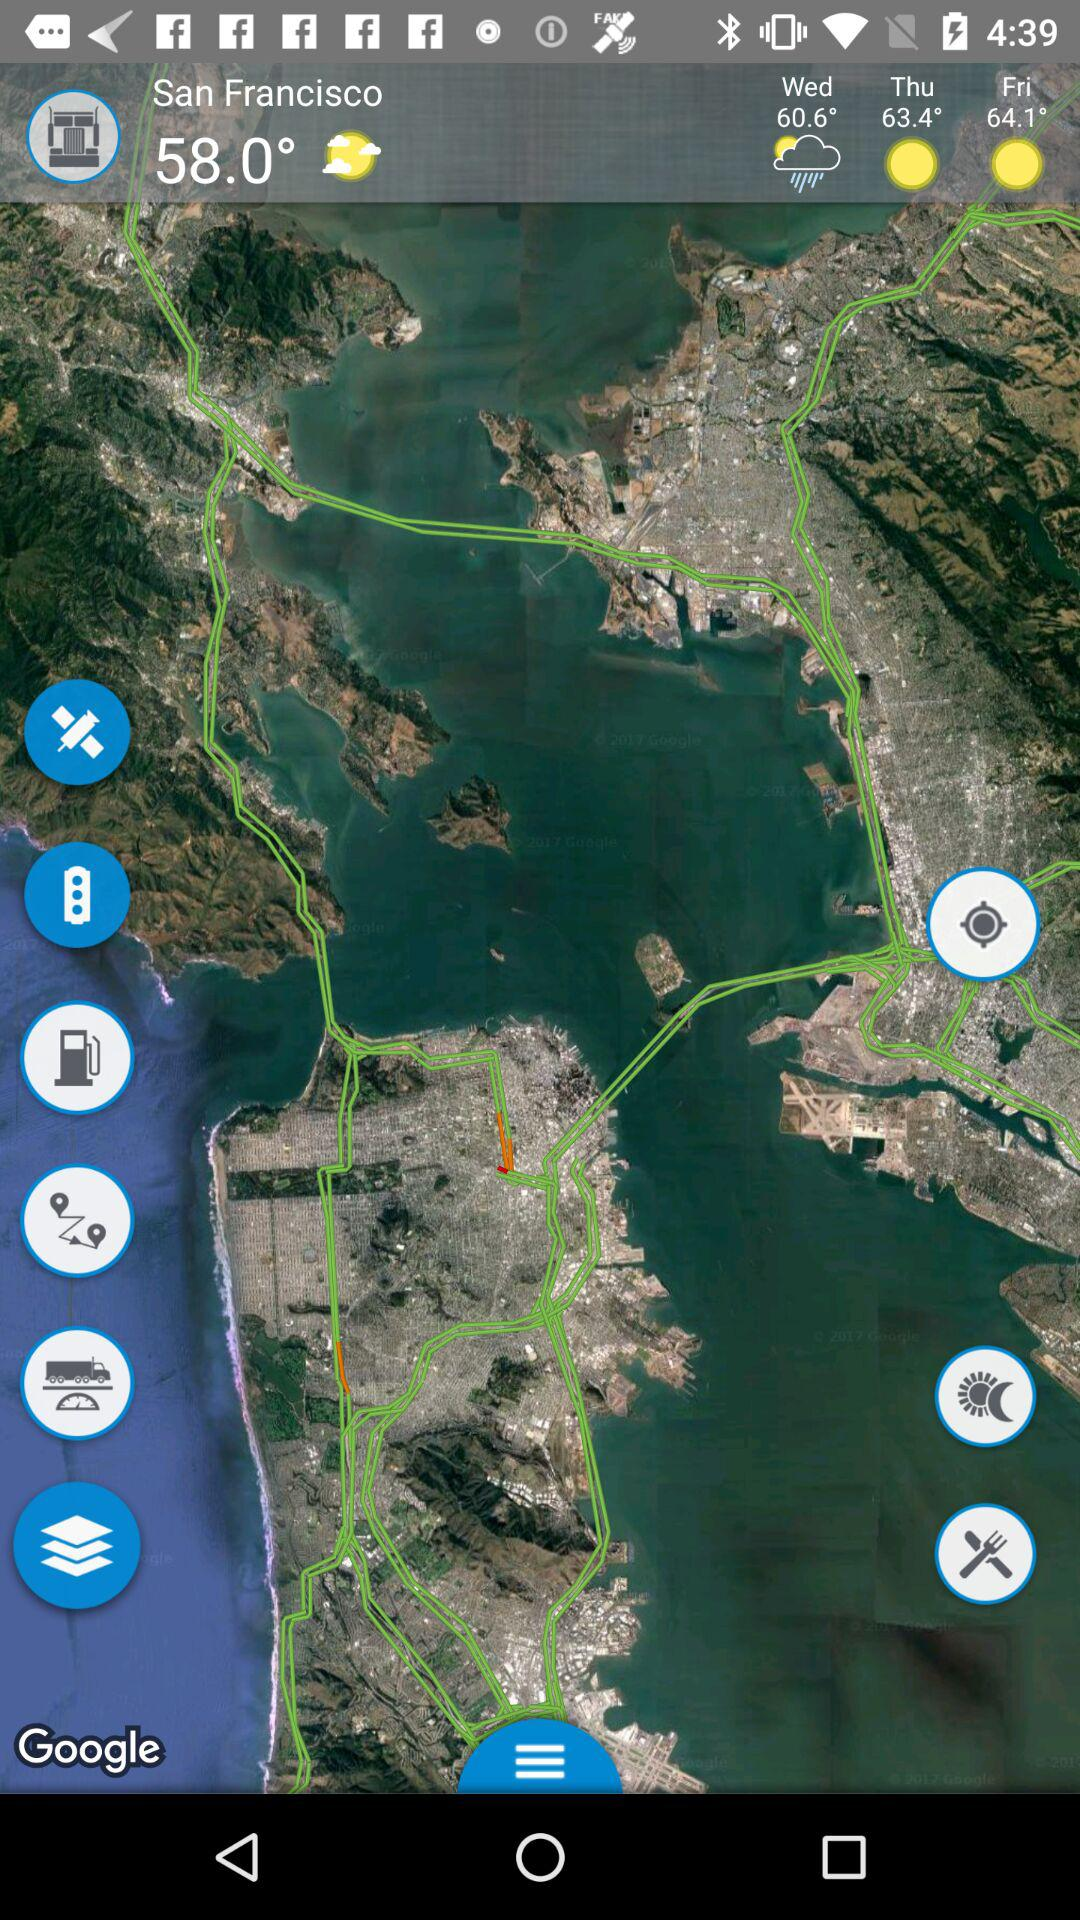What is the temperature in San Francisco? The temperature is 58.0°. 